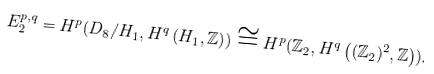Convert formula to latex. <formula><loc_0><loc_0><loc_500><loc_500>E _ { 2 } ^ { p , q } = H ^ { p } ( D _ { 8 } / H _ { 1 } , H ^ { q } \left ( H _ { 1 } , \mathbb { Z } \right ) ) \cong H ^ { p } ( \mathbb { Z } _ { 2 } , H ^ { q } \left ( ( \mathbb { Z } _ { 2 } ) ^ { 2 } , \mathbb { Z } \right ) ) .</formula> 